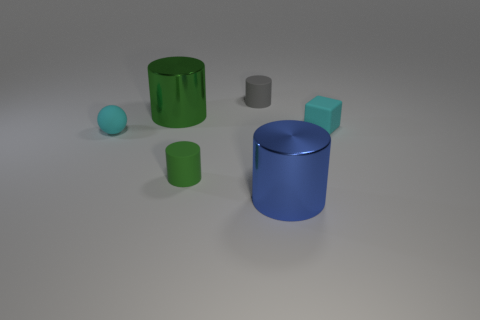Is it possible to infer the relative weights of these objects? While it's challenging to accurately determine the weights without specific material information, generally, the size and material suggest that the blue cylinder might be the heaviest object, followed by the green rubber cylinder, although the actual weight would depend on the thickness and density of the materials used. 